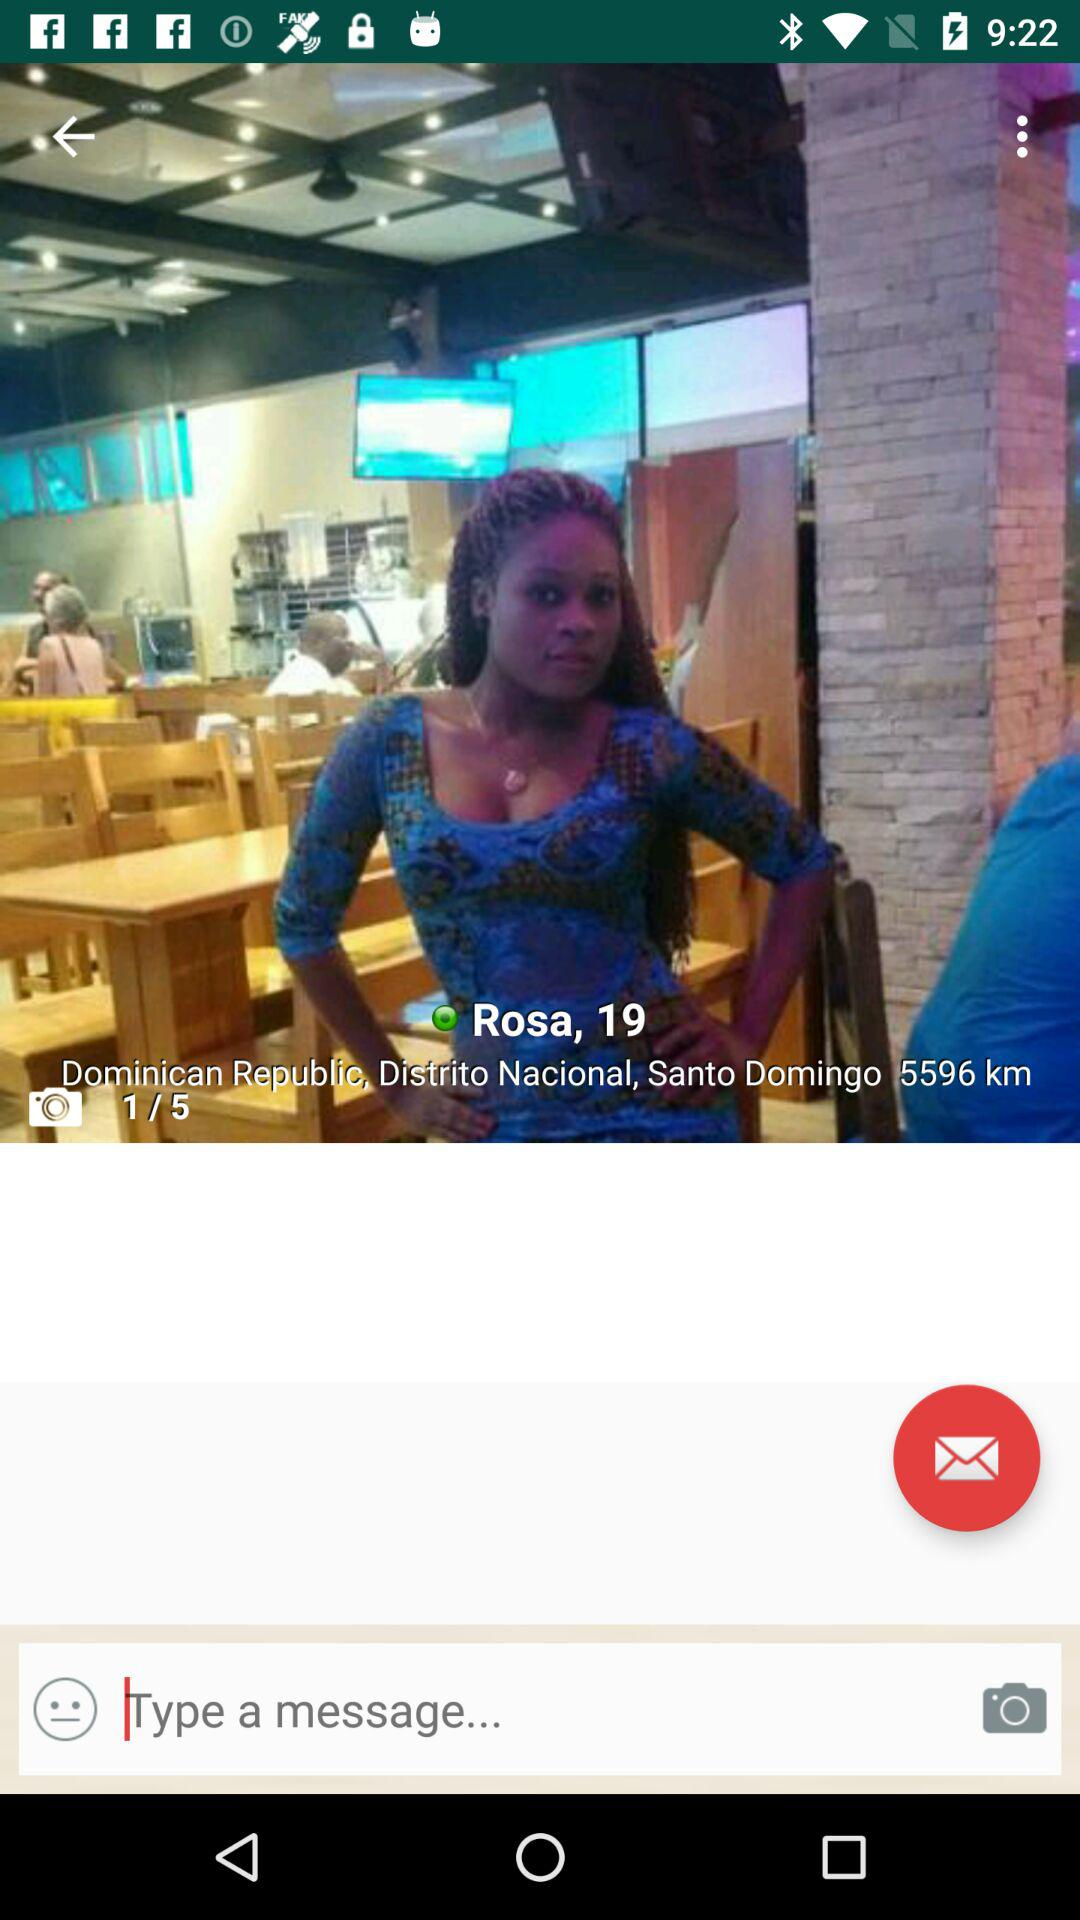How many kilometres are shown on the screen? There are 5596 km shown on the screen. 